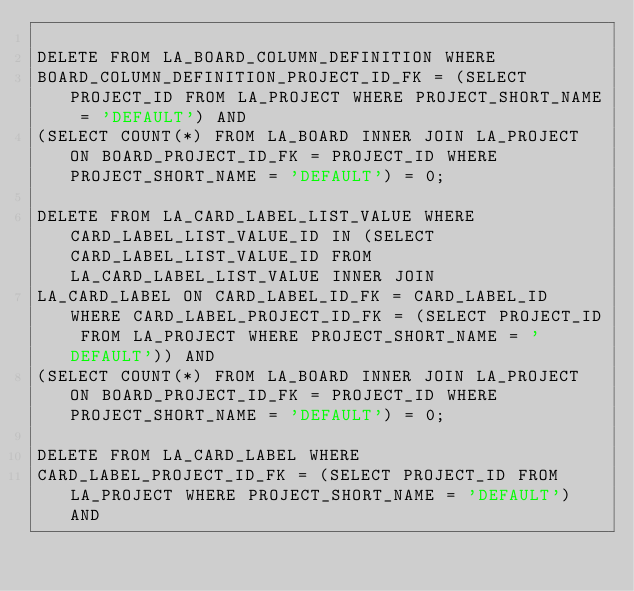<code> <loc_0><loc_0><loc_500><loc_500><_SQL_>
DELETE FROM LA_BOARD_COLUMN_DEFINITION WHERE
BOARD_COLUMN_DEFINITION_PROJECT_ID_FK = (SELECT PROJECT_ID FROM LA_PROJECT WHERE PROJECT_SHORT_NAME = 'DEFAULT') AND
(SELECT COUNT(*) FROM LA_BOARD INNER JOIN LA_PROJECT ON BOARD_PROJECT_ID_FK = PROJECT_ID WHERE PROJECT_SHORT_NAME = 'DEFAULT') = 0;

DELETE FROM LA_CARD_LABEL_LIST_VALUE WHERE CARD_LABEL_LIST_VALUE_ID IN (SELECT CARD_LABEL_LIST_VALUE_ID FROM LA_CARD_LABEL_LIST_VALUE INNER JOIN
LA_CARD_LABEL ON CARD_LABEL_ID_FK = CARD_LABEL_ID WHERE CARD_LABEL_PROJECT_ID_FK = (SELECT PROJECT_ID FROM LA_PROJECT WHERE PROJECT_SHORT_NAME = 'DEFAULT')) AND
(SELECT COUNT(*) FROM LA_BOARD INNER JOIN LA_PROJECT ON BOARD_PROJECT_ID_FK = PROJECT_ID WHERE PROJECT_SHORT_NAME = 'DEFAULT') = 0;

DELETE FROM LA_CARD_LABEL WHERE
CARD_LABEL_PROJECT_ID_FK = (SELECT PROJECT_ID FROM LA_PROJECT WHERE PROJECT_SHORT_NAME = 'DEFAULT') AND</code> 